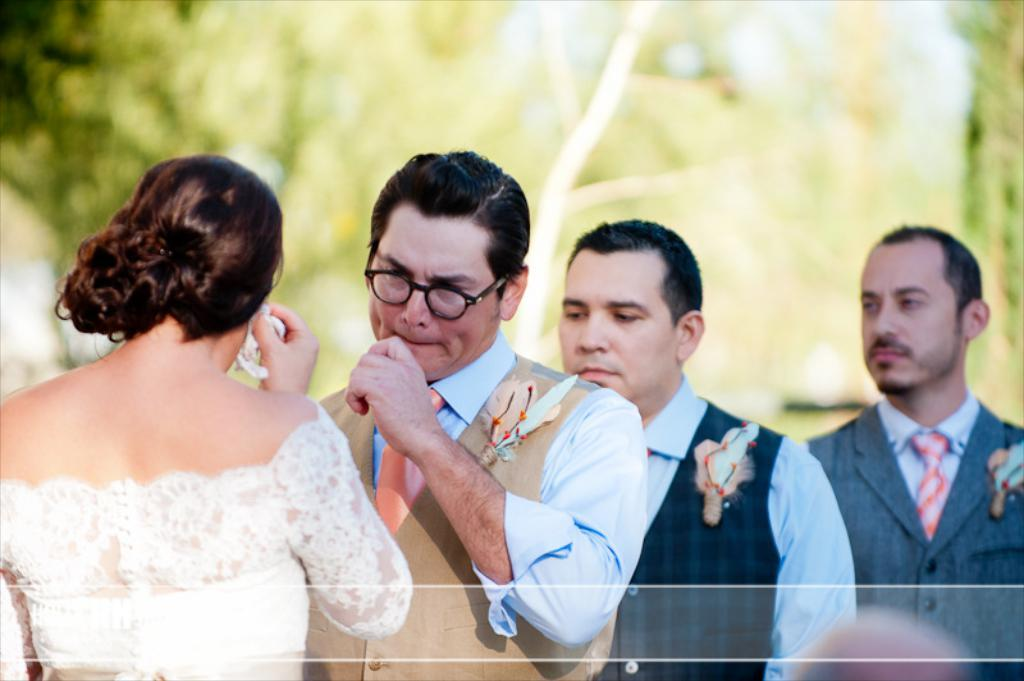What is the woman in the image holding? The woman is holding a tissue. How many people are standing in the image? There are three persons standing in the image. What is the position of one of the persons in the image? There is a person sitting in the image. What can be seen in the background of the image? Trees are visible in the background of the image. What type of dog is sitting next to the woman in the image? There is no dog present in the image. Who is the woman's partner in the image? The provided facts do not mention a partner or any relationship between the people in the image. 